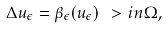Convert formula to latex. <formula><loc_0><loc_0><loc_500><loc_500>\Delta u _ { \epsilon } = \beta _ { \epsilon } ( u _ { \epsilon } ) \ > i n \Omega ,</formula> 